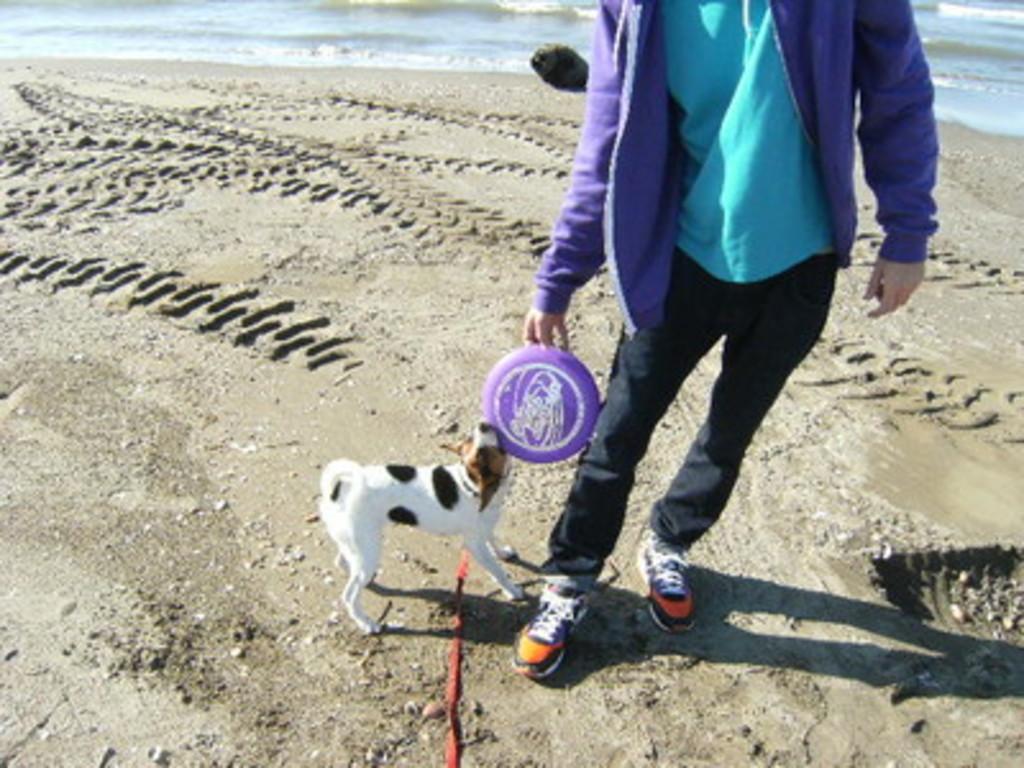In one or two sentences, can you explain what this image depicts? In this image we can see a person playing with a dog, they both are holding an object and in the background there is sand and water. 